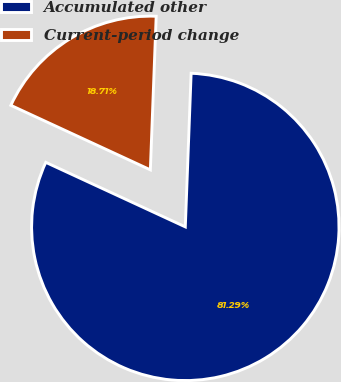<chart> <loc_0><loc_0><loc_500><loc_500><pie_chart><fcel>Accumulated other<fcel>Current-period change<nl><fcel>81.29%<fcel>18.71%<nl></chart> 